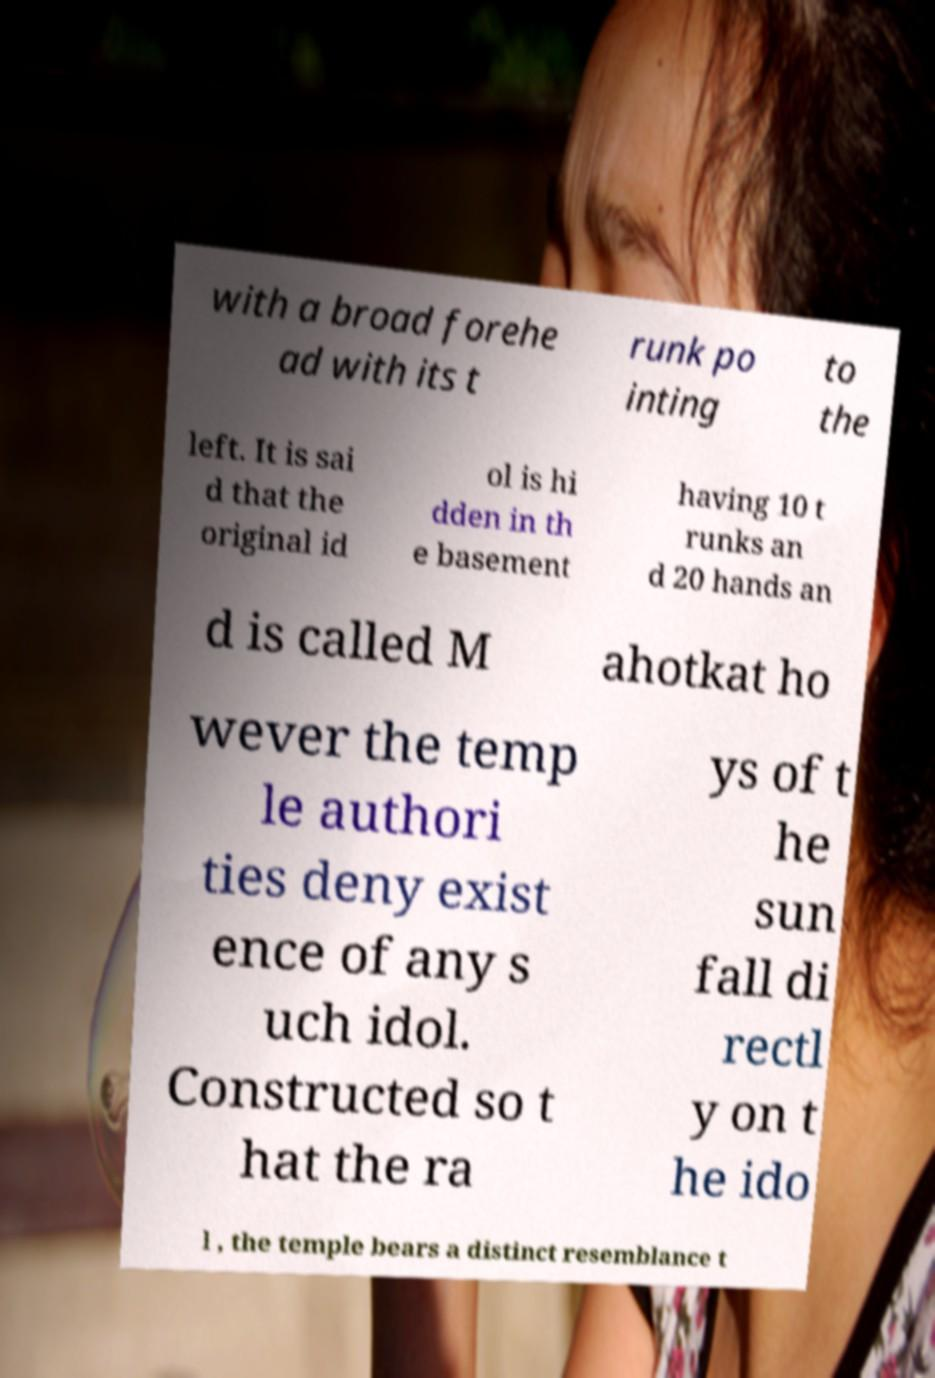I need the written content from this picture converted into text. Can you do that? with a broad forehe ad with its t runk po inting to the left. It is sai d that the original id ol is hi dden in th e basement having 10 t runks an d 20 hands an d is called M ahotkat ho wever the temp le authori ties deny exist ence of any s uch idol. Constructed so t hat the ra ys of t he sun fall di rectl y on t he ido l , the temple bears a distinct resemblance t 